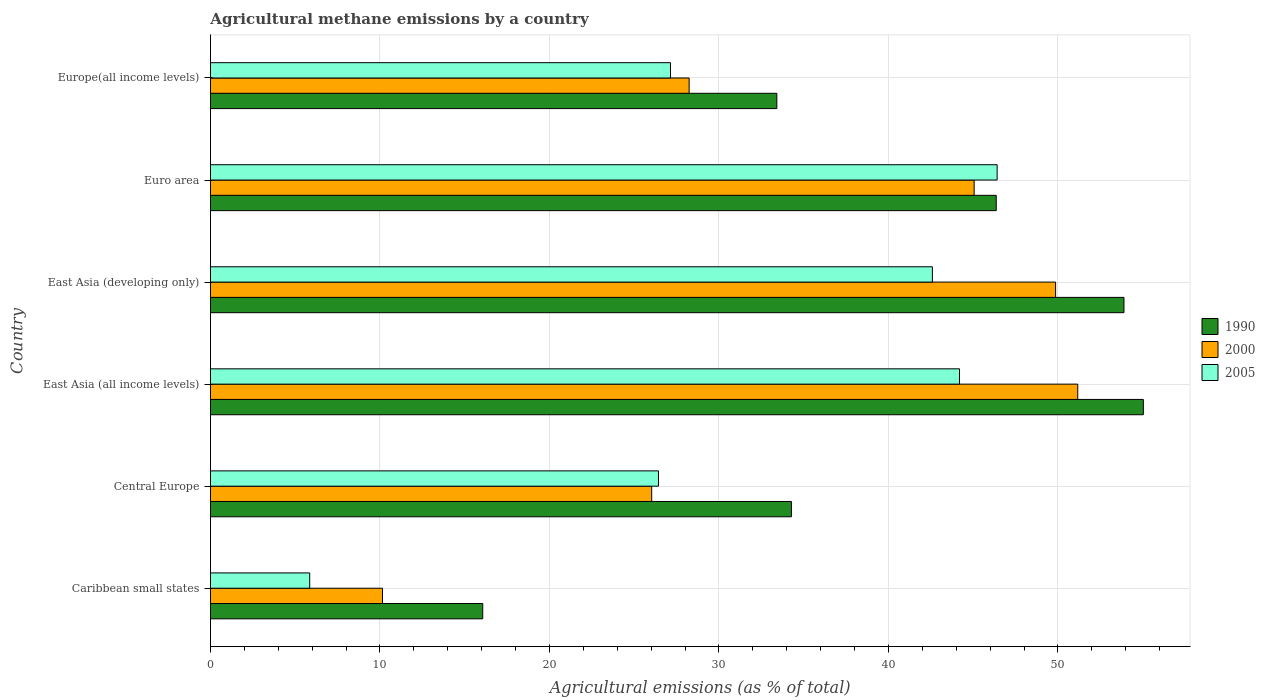How many different coloured bars are there?
Give a very brief answer. 3. How many groups of bars are there?
Offer a very short reply. 6. How many bars are there on the 2nd tick from the bottom?
Keep it short and to the point. 3. What is the label of the 5th group of bars from the top?
Keep it short and to the point. Central Europe. What is the amount of agricultural methane emitted in 2005 in East Asia (developing only)?
Offer a terse response. 42.59. Across all countries, what is the maximum amount of agricultural methane emitted in 2005?
Provide a short and direct response. 46.41. Across all countries, what is the minimum amount of agricultural methane emitted in 2005?
Provide a succinct answer. 5.85. In which country was the amount of agricultural methane emitted in 2000 minimum?
Your answer should be very brief. Caribbean small states. What is the total amount of agricultural methane emitted in 1990 in the graph?
Ensure brevity in your answer.  239.04. What is the difference between the amount of agricultural methane emitted in 2000 in East Asia (all income levels) and that in East Asia (developing only)?
Give a very brief answer. 1.31. What is the difference between the amount of agricultural methane emitted in 2000 in Europe(all income levels) and the amount of agricultural methane emitted in 2005 in Central Europe?
Make the answer very short. 1.81. What is the average amount of agricultural methane emitted in 2000 per country?
Offer a terse response. 35.08. What is the difference between the amount of agricultural methane emitted in 2005 and amount of agricultural methane emitted in 1990 in East Asia (all income levels)?
Make the answer very short. -10.85. In how many countries, is the amount of agricultural methane emitted in 2005 greater than 42 %?
Provide a short and direct response. 3. What is the ratio of the amount of agricultural methane emitted in 2000 in Caribbean small states to that in Europe(all income levels)?
Your answer should be very brief. 0.36. Is the difference between the amount of agricultural methane emitted in 2005 in Caribbean small states and East Asia (all income levels) greater than the difference between the amount of agricultural methane emitted in 1990 in Caribbean small states and East Asia (all income levels)?
Your answer should be very brief. Yes. What is the difference between the highest and the second highest amount of agricultural methane emitted in 1990?
Offer a very short reply. 1.14. What is the difference between the highest and the lowest amount of agricultural methane emitted in 2000?
Offer a terse response. 41.02. In how many countries, is the amount of agricultural methane emitted in 1990 greater than the average amount of agricultural methane emitted in 1990 taken over all countries?
Your answer should be very brief. 3. Is the sum of the amount of agricultural methane emitted in 1990 in Caribbean small states and East Asia (developing only) greater than the maximum amount of agricultural methane emitted in 2000 across all countries?
Ensure brevity in your answer.  Yes. What does the 3rd bar from the top in Caribbean small states represents?
Give a very brief answer. 1990. Where does the legend appear in the graph?
Provide a short and direct response. Center right. How are the legend labels stacked?
Keep it short and to the point. Vertical. What is the title of the graph?
Keep it short and to the point. Agricultural methane emissions by a country. Does "1997" appear as one of the legend labels in the graph?
Make the answer very short. No. What is the label or title of the X-axis?
Your answer should be very brief. Agricultural emissions (as % of total). What is the Agricultural emissions (as % of total) of 1990 in Caribbean small states?
Offer a very short reply. 16.06. What is the Agricultural emissions (as % of total) of 2000 in Caribbean small states?
Ensure brevity in your answer.  10.15. What is the Agricultural emissions (as % of total) of 2005 in Caribbean small states?
Make the answer very short. 5.85. What is the Agricultural emissions (as % of total) of 1990 in Central Europe?
Offer a very short reply. 34.27. What is the Agricultural emissions (as % of total) in 2000 in Central Europe?
Provide a short and direct response. 26.03. What is the Agricultural emissions (as % of total) of 2005 in Central Europe?
Offer a very short reply. 26.43. What is the Agricultural emissions (as % of total) of 1990 in East Asia (all income levels)?
Offer a very short reply. 55.04. What is the Agricultural emissions (as % of total) in 2000 in East Asia (all income levels)?
Offer a terse response. 51.17. What is the Agricultural emissions (as % of total) in 2005 in East Asia (all income levels)?
Offer a terse response. 44.19. What is the Agricultural emissions (as % of total) of 1990 in East Asia (developing only)?
Make the answer very short. 53.89. What is the Agricultural emissions (as % of total) in 2000 in East Asia (developing only)?
Ensure brevity in your answer.  49.86. What is the Agricultural emissions (as % of total) of 2005 in East Asia (developing only)?
Ensure brevity in your answer.  42.59. What is the Agricultural emissions (as % of total) in 1990 in Euro area?
Offer a very short reply. 46.36. What is the Agricultural emissions (as % of total) of 2000 in Euro area?
Your response must be concise. 45.06. What is the Agricultural emissions (as % of total) in 2005 in Euro area?
Offer a very short reply. 46.41. What is the Agricultural emissions (as % of total) in 1990 in Europe(all income levels)?
Give a very brief answer. 33.41. What is the Agricultural emissions (as % of total) in 2000 in Europe(all income levels)?
Provide a succinct answer. 28.24. What is the Agricultural emissions (as % of total) of 2005 in Europe(all income levels)?
Your answer should be very brief. 27.14. Across all countries, what is the maximum Agricultural emissions (as % of total) of 1990?
Provide a succinct answer. 55.04. Across all countries, what is the maximum Agricultural emissions (as % of total) in 2000?
Make the answer very short. 51.17. Across all countries, what is the maximum Agricultural emissions (as % of total) in 2005?
Keep it short and to the point. 46.41. Across all countries, what is the minimum Agricultural emissions (as % of total) in 1990?
Ensure brevity in your answer.  16.06. Across all countries, what is the minimum Agricultural emissions (as % of total) in 2000?
Keep it short and to the point. 10.15. Across all countries, what is the minimum Agricultural emissions (as % of total) of 2005?
Make the answer very short. 5.85. What is the total Agricultural emissions (as % of total) of 1990 in the graph?
Your answer should be compact. 239.04. What is the total Agricultural emissions (as % of total) of 2000 in the graph?
Your answer should be compact. 210.5. What is the total Agricultural emissions (as % of total) in 2005 in the graph?
Keep it short and to the point. 192.62. What is the difference between the Agricultural emissions (as % of total) of 1990 in Caribbean small states and that in Central Europe?
Your answer should be compact. -18.21. What is the difference between the Agricultural emissions (as % of total) of 2000 in Caribbean small states and that in Central Europe?
Your answer should be very brief. -15.88. What is the difference between the Agricultural emissions (as % of total) of 2005 in Caribbean small states and that in Central Europe?
Provide a short and direct response. -20.58. What is the difference between the Agricultural emissions (as % of total) of 1990 in Caribbean small states and that in East Asia (all income levels)?
Ensure brevity in your answer.  -38.97. What is the difference between the Agricultural emissions (as % of total) of 2000 in Caribbean small states and that in East Asia (all income levels)?
Your answer should be compact. -41.02. What is the difference between the Agricultural emissions (as % of total) of 2005 in Caribbean small states and that in East Asia (all income levels)?
Make the answer very short. -38.34. What is the difference between the Agricultural emissions (as % of total) in 1990 in Caribbean small states and that in East Asia (developing only)?
Offer a terse response. -37.83. What is the difference between the Agricultural emissions (as % of total) of 2000 in Caribbean small states and that in East Asia (developing only)?
Provide a succinct answer. -39.71. What is the difference between the Agricultural emissions (as % of total) in 2005 in Caribbean small states and that in East Asia (developing only)?
Your answer should be compact. -36.74. What is the difference between the Agricultural emissions (as % of total) of 1990 in Caribbean small states and that in Euro area?
Keep it short and to the point. -30.29. What is the difference between the Agricultural emissions (as % of total) in 2000 in Caribbean small states and that in Euro area?
Make the answer very short. -34.91. What is the difference between the Agricultural emissions (as % of total) in 2005 in Caribbean small states and that in Euro area?
Provide a short and direct response. -40.56. What is the difference between the Agricultural emissions (as % of total) in 1990 in Caribbean small states and that in Europe(all income levels)?
Your answer should be compact. -17.35. What is the difference between the Agricultural emissions (as % of total) of 2000 in Caribbean small states and that in Europe(all income levels)?
Provide a short and direct response. -18.09. What is the difference between the Agricultural emissions (as % of total) in 2005 in Caribbean small states and that in Europe(all income levels)?
Your response must be concise. -21.29. What is the difference between the Agricultural emissions (as % of total) in 1990 in Central Europe and that in East Asia (all income levels)?
Provide a succinct answer. -20.76. What is the difference between the Agricultural emissions (as % of total) in 2000 in Central Europe and that in East Asia (all income levels)?
Your response must be concise. -25.14. What is the difference between the Agricultural emissions (as % of total) in 2005 in Central Europe and that in East Asia (all income levels)?
Provide a succinct answer. -17.76. What is the difference between the Agricultural emissions (as % of total) of 1990 in Central Europe and that in East Asia (developing only)?
Your answer should be compact. -19.62. What is the difference between the Agricultural emissions (as % of total) of 2000 in Central Europe and that in East Asia (developing only)?
Provide a short and direct response. -23.83. What is the difference between the Agricultural emissions (as % of total) of 2005 in Central Europe and that in East Asia (developing only)?
Give a very brief answer. -16.16. What is the difference between the Agricultural emissions (as % of total) in 1990 in Central Europe and that in Euro area?
Provide a succinct answer. -12.08. What is the difference between the Agricultural emissions (as % of total) of 2000 in Central Europe and that in Euro area?
Ensure brevity in your answer.  -19.03. What is the difference between the Agricultural emissions (as % of total) of 2005 in Central Europe and that in Euro area?
Make the answer very short. -19.98. What is the difference between the Agricultural emissions (as % of total) in 1990 in Central Europe and that in Europe(all income levels)?
Your response must be concise. 0.86. What is the difference between the Agricultural emissions (as % of total) of 2000 in Central Europe and that in Europe(all income levels)?
Keep it short and to the point. -2.21. What is the difference between the Agricultural emissions (as % of total) of 2005 in Central Europe and that in Europe(all income levels)?
Ensure brevity in your answer.  -0.71. What is the difference between the Agricultural emissions (as % of total) of 1990 in East Asia (all income levels) and that in East Asia (developing only)?
Your answer should be compact. 1.14. What is the difference between the Agricultural emissions (as % of total) in 2000 in East Asia (all income levels) and that in East Asia (developing only)?
Provide a short and direct response. 1.31. What is the difference between the Agricultural emissions (as % of total) in 2005 in East Asia (all income levels) and that in East Asia (developing only)?
Your answer should be compact. 1.6. What is the difference between the Agricultural emissions (as % of total) of 1990 in East Asia (all income levels) and that in Euro area?
Offer a very short reply. 8.68. What is the difference between the Agricultural emissions (as % of total) in 2000 in East Asia (all income levels) and that in Euro area?
Your answer should be compact. 6.11. What is the difference between the Agricultural emissions (as % of total) in 2005 in East Asia (all income levels) and that in Euro area?
Ensure brevity in your answer.  -2.22. What is the difference between the Agricultural emissions (as % of total) in 1990 in East Asia (all income levels) and that in Europe(all income levels)?
Provide a succinct answer. 21.62. What is the difference between the Agricultural emissions (as % of total) of 2000 in East Asia (all income levels) and that in Europe(all income levels)?
Give a very brief answer. 22.93. What is the difference between the Agricultural emissions (as % of total) in 2005 in East Asia (all income levels) and that in Europe(all income levels)?
Your answer should be very brief. 17.05. What is the difference between the Agricultural emissions (as % of total) in 1990 in East Asia (developing only) and that in Euro area?
Offer a terse response. 7.54. What is the difference between the Agricultural emissions (as % of total) in 2000 in East Asia (developing only) and that in Euro area?
Keep it short and to the point. 4.8. What is the difference between the Agricultural emissions (as % of total) of 2005 in East Asia (developing only) and that in Euro area?
Your response must be concise. -3.82. What is the difference between the Agricultural emissions (as % of total) of 1990 in East Asia (developing only) and that in Europe(all income levels)?
Offer a terse response. 20.48. What is the difference between the Agricultural emissions (as % of total) of 2000 in East Asia (developing only) and that in Europe(all income levels)?
Provide a short and direct response. 21.62. What is the difference between the Agricultural emissions (as % of total) in 2005 in East Asia (developing only) and that in Europe(all income levels)?
Your response must be concise. 15.45. What is the difference between the Agricultural emissions (as % of total) in 1990 in Euro area and that in Europe(all income levels)?
Your answer should be compact. 12.94. What is the difference between the Agricultural emissions (as % of total) of 2000 in Euro area and that in Europe(all income levels)?
Ensure brevity in your answer.  16.82. What is the difference between the Agricultural emissions (as % of total) in 2005 in Euro area and that in Europe(all income levels)?
Your response must be concise. 19.27. What is the difference between the Agricultural emissions (as % of total) in 1990 in Caribbean small states and the Agricultural emissions (as % of total) in 2000 in Central Europe?
Keep it short and to the point. -9.97. What is the difference between the Agricultural emissions (as % of total) of 1990 in Caribbean small states and the Agricultural emissions (as % of total) of 2005 in Central Europe?
Offer a terse response. -10.37. What is the difference between the Agricultural emissions (as % of total) in 2000 in Caribbean small states and the Agricultural emissions (as % of total) in 2005 in Central Europe?
Ensure brevity in your answer.  -16.28. What is the difference between the Agricultural emissions (as % of total) of 1990 in Caribbean small states and the Agricultural emissions (as % of total) of 2000 in East Asia (all income levels)?
Keep it short and to the point. -35.1. What is the difference between the Agricultural emissions (as % of total) in 1990 in Caribbean small states and the Agricultural emissions (as % of total) in 2005 in East Asia (all income levels)?
Provide a short and direct response. -28.13. What is the difference between the Agricultural emissions (as % of total) in 2000 in Caribbean small states and the Agricultural emissions (as % of total) in 2005 in East Asia (all income levels)?
Your response must be concise. -34.04. What is the difference between the Agricultural emissions (as % of total) of 1990 in Caribbean small states and the Agricultural emissions (as % of total) of 2000 in East Asia (developing only)?
Provide a succinct answer. -33.8. What is the difference between the Agricultural emissions (as % of total) of 1990 in Caribbean small states and the Agricultural emissions (as % of total) of 2005 in East Asia (developing only)?
Provide a succinct answer. -26.53. What is the difference between the Agricultural emissions (as % of total) of 2000 in Caribbean small states and the Agricultural emissions (as % of total) of 2005 in East Asia (developing only)?
Provide a short and direct response. -32.44. What is the difference between the Agricultural emissions (as % of total) of 1990 in Caribbean small states and the Agricultural emissions (as % of total) of 2000 in Euro area?
Offer a very short reply. -28.99. What is the difference between the Agricultural emissions (as % of total) of 1990 in Caribbean small states and the Agricultural emissions (as % of total) of 2005 in Euro area?
Your answer should be compact. -30.35. What is the difference between the Agricultural emissions (as % of total) of 2000 in Caribbean small states and the Agricultural emissions (as % of total) of 2005 in Euro area?
Provide a succinct answer. -36.26. What is the difference between the Agricultural emissions (as % of total) in 1990 in Caribbean small states and the Agricultural emissions (as % of total) in 2000 in Europe(all income levels)?
Keep it short and to the point. -12.18. What is the difference between the Agricultural emissions (as % of total) of 1990 in Caribbean small states and the Agricultural emissions (as % of total) of 2005 in Europe(all income levels)?
Your answer should be compact. -11.08. What is the difference between the Agricultural emissions (as % of total) of 2000 in Caribbean small states and the Agricultural emissions (as % of total) of 2005 in Europe(all income levels)?
Ensure brevity in your answer.  -16.99. What is the difference between the Agricultural emissions (as % of total) in 1990 in Central Europe and the Agricultural emissions (as % of total) in 2000 in East Asia (all income levels)?
Your answer should be very brief. -16.89. What is the difference between the Agricultural emissions (as % of total) of 1990 in Central Europe and the Agricultural emissions (as % of total) of 2005 in East Asia (all income levels)?
Provide a succinct answer. -9.92. What is the difference between the Agricultural emissions (as % of total) in 2000 in Central Europe and the Agricultural emissions (as % of total) in 2005 in East Asia (all income levels)?
Your answer should be very brief. -18.16. What is the difference between the Agricultural emissions (as % of total) of 1990 in Central Europe and the Agricultural emissions (as % of total) of 2000 in East Asia (developing only)?
Provide a succinct answer. -15.59. What is the difference between the Agricultural emissions (as % of total) in 1990 in Central Europe and the Agricultural emissions (as % of total) in 2005 in East Asia (developing only)?
Your answer should be very brief. -8.32. What is the difference between the Agricultural emissions (as % of total) in 2000 in Central Europe and the Agricultural emissions (as % of total) in 2005 in East Asia (developing only)?
Your response must be concise. -16.56. What is the difference between the Agricultural emissions (as % of total) of 1990 in Central Europe and the Agricultural emissions (as % of total) of 2000 in Euro area?
Give a very brief answer. -10.78. What is the difference between the Agricultural emissions (as % of total) of 1990 in Central Europe and the Agricultural emissions (as % of total) of 2005 in Euro area?
Offer a very short reply. -12.14. What is the difference between the Agricultural emissions (as % of total) of 2000 in Central Europe and the Agricultural emissions (as % of total) of 2005 in Euro area?
Your answer should be compact. -20.38. What is the difference between the Agricultural emissions (as % of total) of 1990 in Central Europe and the Agricultural emissions (as % of total) of 2000 in Europe(all income levels)?
Keep it short and to the point. 6.03. What is the difference between the Agricultural emissions (as % of total) of 1990 in Central Europe and the Agricultural emissions (as % of total) of 2005 in Europe(all income levels)?
Your answer should be very brief. 7.13. What is the difference between the Agricultural emissions (as % of total) in 2000 in Central Europe and the Agricultural emissions (as % of total) in 2005 in Europe(all income levels)?
Your response must be concise. -1.11. What is the difference between the Agricultural emissions (as % of total) in 1990 in East Asia (all income levels) and the Agricultural emissions (as % of total) in 2000 in East Asia (developing only)?
Provide a succinct answer. 5.18. What is the difference between the Agricultural emissions (as % of total) in 1990 in East Asia (all income levels) and the Agricultural emissions (as % of total) in 2005 in East Asia (developing only)?
Make the answer very short. 12.45. What is the difference between the Agricultural emissions (as % of total) of 2000 in East Asia (all income levels) and the Agricultural emissions (as % of total) of 2005 in East Asia (developing only)?
Provide a succinct answer. 8.58. What is the difference between the Agricultural emissions (as % of total) in 1990 in East Asia (all income levels) and the Agricultural emissions (as % of total) in 2000 in Euro area?
Offer a terse response. 9.98. What is the difference between the Agricultural emissions (as % of total) in 1990 in East Asia (all income levels) and the Agricultural emissions (as % of total) in 2005 in Euro area?
Your response must be concise. 8.63. What is the difference between the Agricultural emissions (as % of total) in 2000 in East Asia (all income levels) and the Agricultural emissions (as % of total) in 2005 in Euro area?
Provide a short and direct response. 4.76. What is the difference between the Agricultural emissions (as % of total) in 1990 in East Asia (all income levels) and the Agricultural emissions (as % of total) in 2000 in Europe(all income levels)?
Give a very brief answer. 26.8. What is the difference between the Agricultural emissions (as % of total) in 1990 in East Asia (all income levels) and the Agricultural emissions (as % of total) in 2005 in Europe(all income levels)?
Give a very brief answer. 27.9. What is the difference between the Agricultural emissions (as % of total) in 2000 in East Asia (all income levels) and the Agricultural emissions (as % of total) in 2005 in Europe(all income levels)?
Your answer should be compact. 24.03. What is the difference between the Agricultural emissions (as % of total) in 1990 in East Asia (developing only) and the Agricultural emissions (as % of total) in 2000 in Euro area?
Make the answer very short. 8.84. What is the difference between the Agricultural emissions (as % of total) of 1990 in East Asia (developing only) and the Agricultural emissions (as % of total) of 2005 in Euro area?
Your answer should be very brief. 7.48. What is the difference between the Agricultural emissions (as % of total) of 2000 in East Asia (developing only) and the Agricultural emissions (as % of total) of 2005 in Euro area?
Your response must be concise. 3.45. What is the difference between the Agricultural emissions (as % of total) in 1990 in East Asia (developing only) and the Agricultural emissions (as % of total) in 2000 in Europe(all income levels)?
Give a very brief answer. 25.65. What is the difference between the Agricultural emissions (as % of total) in 1990 in East Asia (developing only) and the Agricultural emissions (as % of total) in 2005 in Europe(all income levels)?
Make the answer very short. 26.75. What is the difference between the Agricultural emissions (as % of total) of 2000 in East Asia (developing only) and the Agricultural emissions (as % of total) of 2005 in Europe(all income levels)?
Ensure brevity in your answer.  22.72. What is the difference between the Agricultural emissions (as % of total) in 1990 in Euro area and the Agricultural emissions (as % of total) in 2000 in Europe(all income levels)?
Offer a terse response. 18.12. What is the difference between the Agricultural emissions (as % of total) in 1990 in Euro area and the Agricultural emissions (as % of total) in 2005 in Europe(all income levels)?
Ensure brevity in your answer.  19.22. What is the difference between the Agricultural emissions (as % of total) in 2000 in Euro area and the Agricultural emissions (as % of total) in 2005 in Europe(all income levels)?
Provide a succinct answer. 17.91. What is the average Agricultural emissions (as % of total) of 1990 per country?
Ensure brevity in your answer.  39.84. What is the average Agricultural emissions (as % of total) in 2000 per country?
Keep it short and to the point. 35.08. What is the average Agricultural emissions (as % of total) in 2005 per country?
Provide a short and direct response. 32.1. What is the difference between the Agricultural emissions (as % of total) of 1990 and Agricultural emissions (as % of total) of 2000 in Caribbean small states?
Keep it short and to the point. 5.91. What is the difference between the Agricultural emissions (as % of total) of 1990 and Agricultural emissions (as % of total) of 2005 in Caribbean small states?
Ensure brevity in your answer.  10.21. What is the difference between the Agricultural emissions (as % of total) of 2000 and Agricultural emissions (as % of total) of 2005 in Caribbean small states?
Provide a short and direct response. 4.29. What is the difference between the Agricultural emissions (as % of total) in 1990 and Agricultural emissions (as % of total) in 2000 in Central Europe?
Give a very brief answer. 8.24. What is the difference between the Agricultural emissions (as % of total) in 1990 and Agricultural emissions (as % of total) in 2005 in Central Europe?
Provide a succinct answer. 7.84. What is the difference between the Agricultural emissions (as % of total) of 2000 and Agricultural emissions (as % of total) of 2005 in Central Europe?
Your answer should be compact. -0.4. What is the difference between the Agricultural emissions (as % of total) in 1990 and Agricultural emissions (as % of total) in 2000 in East Asia (all income levels)?
Provide a short and direct response. 3.87. What is the difference between the Agricultural emissions (as % of total) in 1990 and Agricultural emissions (as % of total) in 2005 in East Asia (all income levels)?
Your answer should be very brief. 10.85. What is the difference between the Agricultural emissions (as % of total) in 2000 and Agricultural emissions (as % of total) in 2005 in East Asia (all income levels)?
Provide a succinct answer. 6.98. What is the difference between the Agricultural emissions (as % of total) in 1990 and Agricultural emissions (as % of total) in 2000 in East Asia (developing only)?
Make the answer very short. 4.03. What is the difference between the Agricultural emissions (as % of total) in 1990 and Agricultural emissions (as % of total) in 2005 in East Asia (developing only)?
Keep it short and to the point. 11.3. What is the difference between the Agricultural emissions (as % of total) of 2000 and Agricultural emissions (as % of total) of 2005 in East Asia (developing only)?
Ensure brevity in your answer.  7.27. What is the difference between the Agricultural emissions (as % of total) in 1990 and Agricultural emissions (as % of total) in 2000 in Euro area?
Your answer should be compact. 1.3. What is the difference between the Agricultural emissions (as % of total) in 1990 and Agricultural emissions (as % of total) in 2005 in Euro area?
Provide a succinct answer. -0.05. What is the difference between the Agricultural emissions (as % of total) of 2000 and Agricultural emissions (as % of total) of 2005 in Euro area?
Offer a terse response. -1.36. What is the difference between the Agricultural emissions (as % of total) of 1990 and Agricultural emissions (as % of total) of 2000 in Europe(all income levels)?
Keep it short and to the point. 5.17. What is the difference between the Agricultural emissions (as % of total) in 1990 and Agricultural emissions (as % of total) in 2005 in Europe(all income levels)?
Your answer should be compact. 6.27. What is the difference between the Agricultural emissions (as % of total) of 2000 and Agricultural emissions (as % of total) of 2005 in Europe(all income levels)?
Give a very brief answer. 1.1. What is the ratio of the Agricultural emissions (as % of total) of 1990 in Caribbean small states to that in Central Europe?
Your answer should be compact. 0.47. What is the ratio of the Agricultural emissions (as % of total) of 2000 in Caribbean small states to that in Central Europe?
Provide a short and direct response. 0.39. What is the ratio of the Agricultural emissions (as % of total) of 2005 in Caribbean small states to that in Central Europe?
Your answer should be very brief. 0.22. What is the ratio of the Agricultural emissions (as % of total) in 1990 in Caribbean small states to that in East Asia (all income levels)?
Ensure brevity in your answer.  0.29. What is the ratio of the Agricultural emissions (as % of total) in 2000 in Caribbean small states to that in East Asia (all income levels)?
Make the answer very short. 0.2. What is the ratio of the Agricultural emissions (as % of total) of 2005 in Caribbean small states to that in East Asia (all income levels)?
Ensure brevity in your answer.  0.13. What is the ratio of the Agricultural emissions (as % of total) in 1990 in Caribbean small states to that in East Asia (developing only)?
Offer a very short reply. 0.3. What is the ratio of the Agricultural emissions (as % of total) of 2000 in Caribbean small states to that in East Asia (developing only)?
Ensure brevity in your answer.  0.2. What is the ratio of the Agricultural emissions (as % of total) in 2005 in Caribbean small states to that in East Asia (developing only)?
Provide a succinct answer. 0.14. What is the ratio of the Agricultural emissions (as % of total) of 1990 in Caribbean small states to that in Euro area?
Your response must be concise. 0.35. What is the ratio of the Agricultural emissions (as % of total) of 2000 in Caribbean small states to that in Euro area?
Offer a very short reply. 0.23. What is the ratio of the Agricultural emissions (as % of total) in 2005 in Caribbean small states to that in Euro area?
Make the answer very short. 0.13. What is the ratio of the Agricultural emissions (as % of total) in 1990 in Caribbean small states to that in Europe(all income levels)?
Keep it short and to the point. 0.48. What is the ratio of the Agricultural emissions (as % of total) in 2000 in Caribbean small states to that in Europe(all income levels)?
Keep it short and to the point. 0.36. What is the ratio of the Agricultural emissions (as % of total) of 2005 in Caribbean small states to that in Europe(all income levels)?
Ensure brevity in your answer.  0.22. What is the ratio of the Agricultural emissions (as % of total) in 1990 in Central Europe to that in East Asia (all income levels)?
Provide a short and direct response. 0.62. What is the ratio of the Agricultural emissions (as % of total) in 2000 in Central Europe to that in East Asia (all income levels)?
Your response must be concise. 0.51. What is the ratio of the Agricultural emissions (as % of total) in 2005 in Central Europe to that in East Asia (all income levels)?
Provide a short and direct response. 0.6. What is the ratio of the Agricultural emissions (as % of total) of 1990 in Central Europe to that in East Asia (developing only)?
Make the answer very short. 0.64. What is the ratio of the Agricultural emissions (as % of total) of 2000 in Central Europe to that in East Asia (developing only)?
Make the answer very short. 0.52. What is the ratio of the Agricultural emissions (as % of total) of 2005 in Central Europe to that in East Asia (developing only)?
Make the answer very short. 0.62. What is the ratio of the Agricultural emissions (as % of total) in 1990 in Central Europe to that in Euro area?
Offer a very short reply. 0.74. What is the ratio of the Agricultural emissions (as % of total) of 2000 in Central Europe to that in Euro area?
Offer a terse response. 0.58. What is the ratio of the Agricultural emissions (as % of total) of 2005 in Central Europe to that in Euro area?
Your response must be concise. 0.57. What is the ratio of the Agricultural emissions (as % of total) in 1990 in Central Europe to that in Europe(all income levels)?
Offer a terse response. 1.03. What is the ratio of the Agricultural emissions (as % of total) of 2000 in Central Europe to that in Europe(all income levels)?
Offer a very short reply. 0.92. What is the ratio of the Agricultural emissions (as % of total) in 2005 in Central Europe to that in Europe(all income levels)?
Provide a short and direct response. 0.97. What is the ratio of the Agricultural emissions (as % of total) in 1990 in East Asia (all income levels) to that in East Asia (developing only)?
Provide a succinct answer. 1.02. What is the ratio of the Agricultural emissions (as % of total) of 2000 in East Asia (all income levels) to that in East Asia (developing only)?
Your answer should be very brief. 1.03. What is the ratio of the Agricultural emissions (as % of total) of 2005 in East Asia (all income levels) to that in East Asia (developing only)?
Offer a terse response. 1.04. What is the ratio of the Agricultural emissions (as % of total) in 1990 in East Asia (all income levels) to that in Euro area?
Make the answer very short. 1.19. What is the ratio of the Agricultural emissions (as % of total) in 2000 in East Asia (all income levels) to that in Euro area?
Offer a terse response. 1.14. What is the ratio of the Agricultural emissions (as % of total) of 2005 in East Asia (all income levels) to that in Euro area?
Offer a very short reply. 0.95. What is the ratio of the Agricultural emissions (as % of total) of 1990 in East Asia (all income levels) to that in Europe(all income levels)?
Keep it short and to the point. 1.65. What is the ratio of the Agricultural emissions (as % of total) in 2000 in East Asia (all income levels) to that in Europe(all income levels)?
Keep it short and to the point. 1.81. What is the ratio of the Agricultural emissions (as % of total) in 2005 in East Asia (all income levels) to that in Europe(all income levels)?
Make the answer very short. 1.63. What is the ratio of the Agricultural emissions (as % of total) of 1990 in East Asia (developing only) to that in Euro area?
Provide a short and direct response. 1.16. What is the ratio of the Agricultural emissions (as % of total) in 2000 in East Asia (developing only) to that in Euro area?
Make the answer very short. 1.11. What is the ratio of the Agricultural emissions (as % of total) in 2005 in East Asia (developing only) to that in Euro area?
Ensure brevity in your answer.  0.92. What is the ratio of the Agricultural emissions (as % of total) in 1990 in East Asia (developing only) to that in Europe(all income levels)?
Provide a succinct answer. 1.61. What is the ratio of the Agricultural emissions (as % of total) in 2000 in East Asia (developing only) to that in Europe(all income levels)?
Ensure brevity in your answer.  1.77. What is the ratio of the Agricultural emissions (as % of total) of 2005 in East Asia (developing only) to that in Europe(all income levels)?
Provide a short and direct response. 1.57. What is the ratio of the Agricultural emissions (as % of total) of 1990 in Euro area to that in Europe(all income levels)?
Keep it short and to the point. 1.39. What is the ratio of the Agricultural emissions (as % of total) in 2000 in Euro area to that in Europe(all income levels)?
Your answer should be very brief. 1.6. What is the ratio of the Agricultural emissions (as % of total) of 2005 in Euro area to that in Europe(all income levels)?
Provide a short and direct response. 1.71. What is the difference between the highest and the second highest Agricultural emissions (as % of total) of 1990?
Keep it short and to the point. 1.14. What is the difference between the highest and the second highest Agricultural emissions (as % of total) in 2000?
Give a very brief answer. 1.31. What is the difference between the highest and the second highest Agricultural emissions (as % of total) of 2005?
Your answer should be compact. 2.22. What is the difference between the highest and the lowest Agricultural emissions (as % of total) of 1990?
Provide a succinct answer. 38.97. What is the difference between the highest and the lowest Agricultural emissions (as % of total) of 2000?
Your answer should be very brief. 41.02. What is the difference between the highest and the lowest Agricultural emissions (as % of total) of 2005?
Offer a terse response. 40.56. 